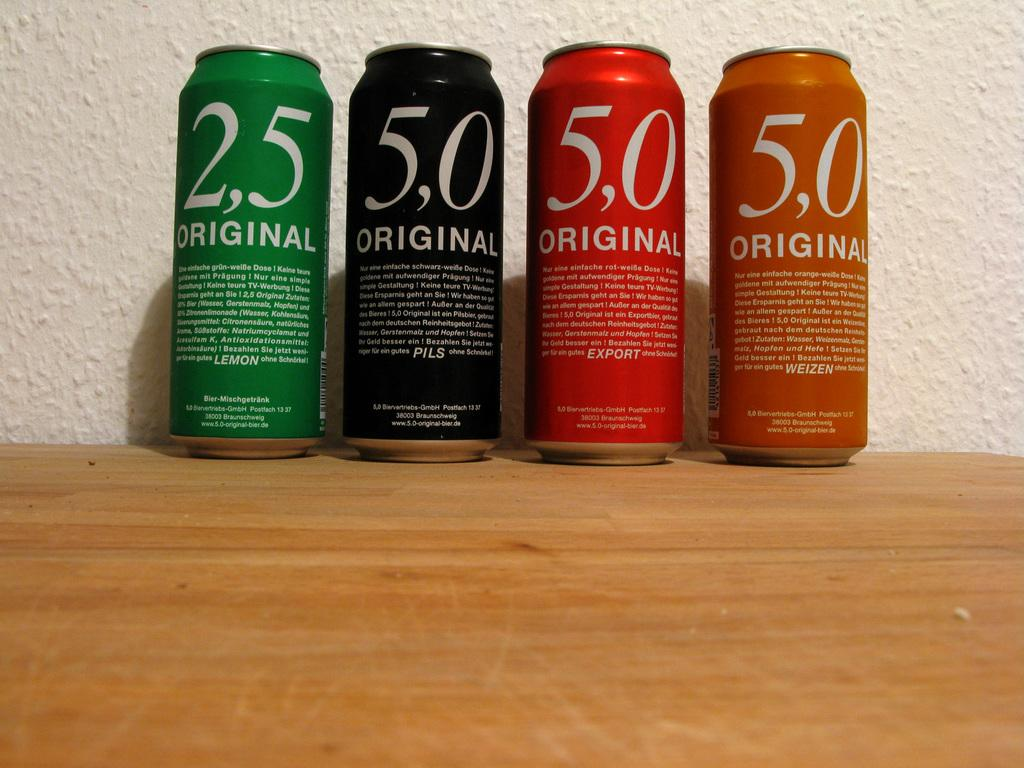<image>
Render a clear and concise summary of the photo. Three cans of 5,0 Original in various colors and one can of 2,5 Original in green. 